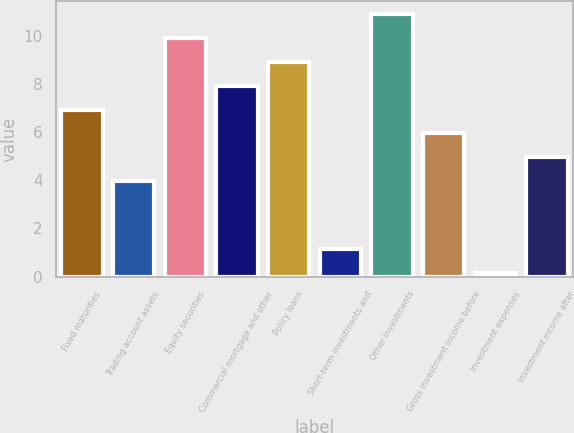Convert chart to OTSL. <chart><loc_0><loc_0><loc_500><loc_500><bar_chart><fcel>Fixed maturities<fcel>Trading account assets<fcel>Equity securities<fcel>Commercial mortgage and other<fcel>Policy loans<fcel>Short-term investments and<fcel>Other investments<fcel>Gross investment income before<fcel>Investment expenses<fcel>Investment income after<nl><fcel>6.93<fcel>3.96<fcel>9.9<fcel>7.92<fcel>8.91<fcel>1.14<fcel>10.89<fcel>5.94<fcel>0.15<fcel>4.95<nl></chart> 